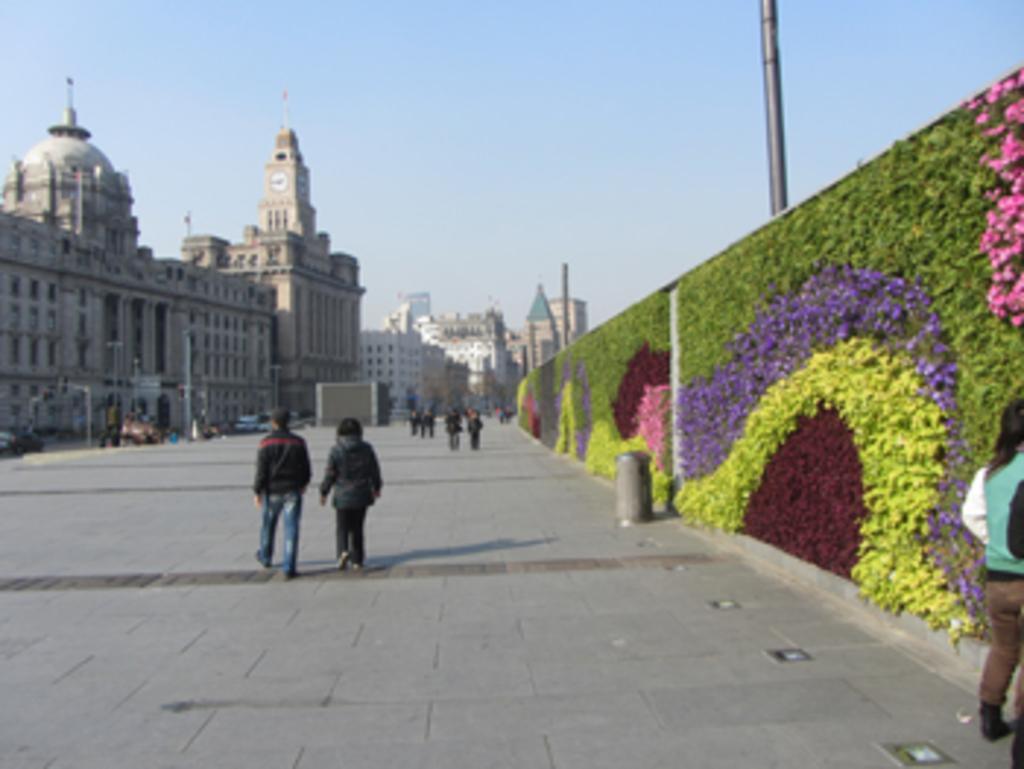Describe this image in one or two sentences. In this image there are a few people walking on the pavement, on the right side of the image there is a trash can and flowers and leaves on the walls, behind the walls there are metal poles. On the left side of the image there are lamp posts in front of buildings and there are some other objects and there are vehicles on the road. 